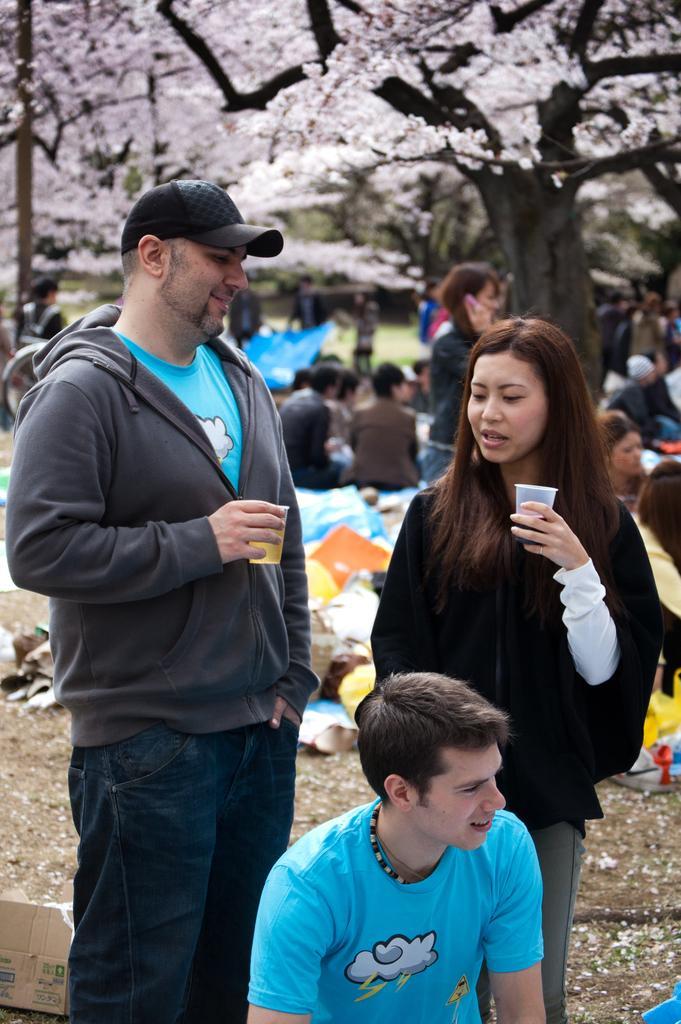Please provide a concise description of this image. In this picture we can see a group of people on the ground, two people are holding glasses with their hands, box, some objects and in the background we can see trees. 